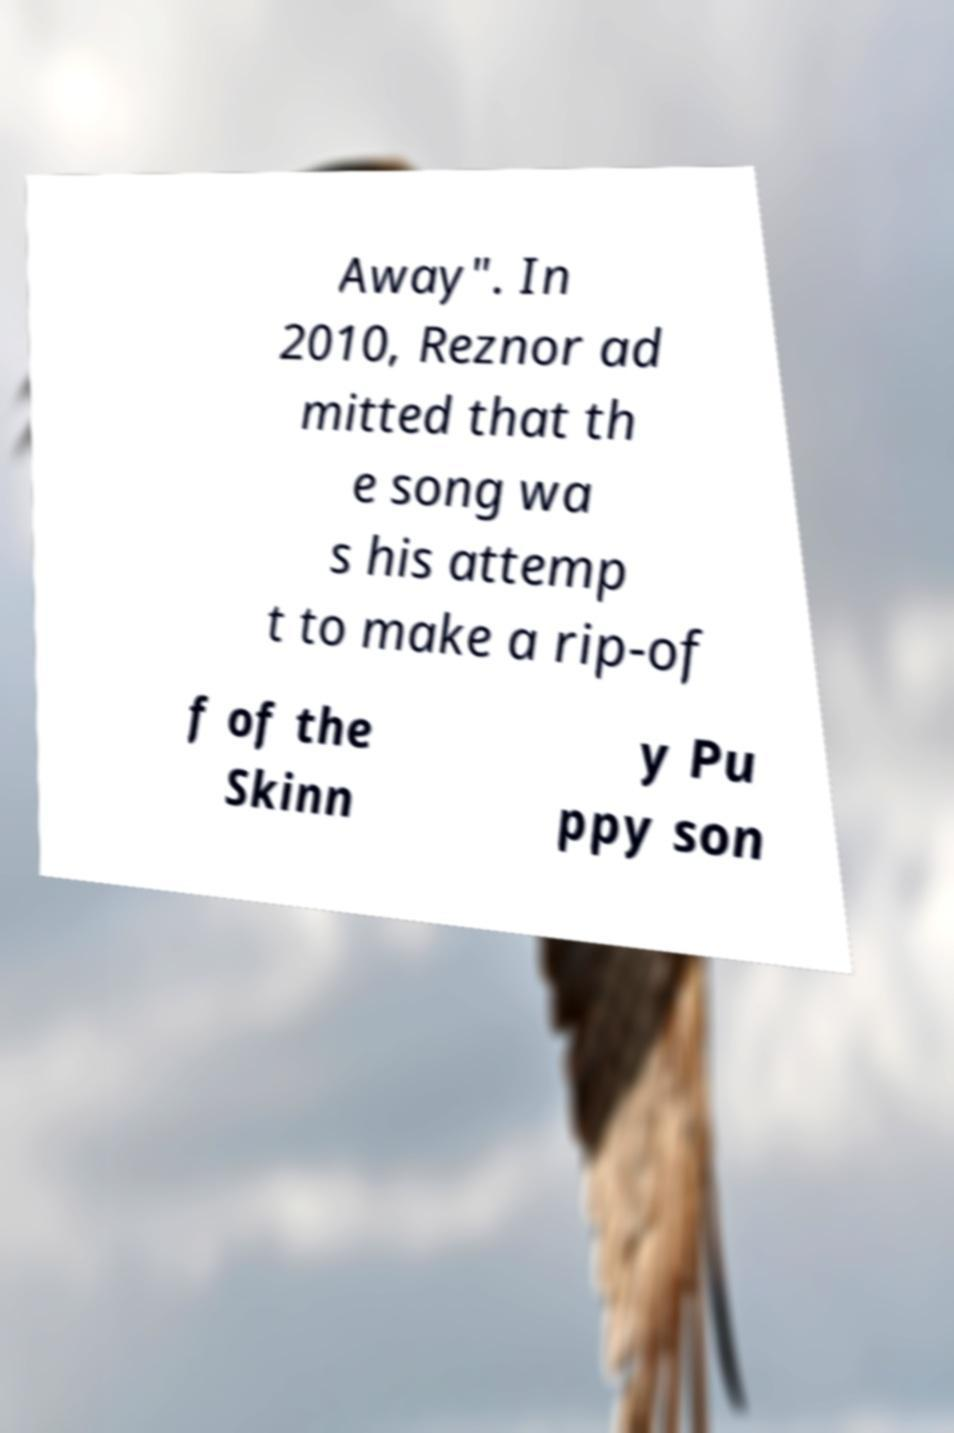What messages or text are displayed in this image? I need them in a readable, typed format. Away". In 2010, Reznor ad mitted that th e song wa s his attemp t to make a rip-of f of the Skinn y Pu ppy son 